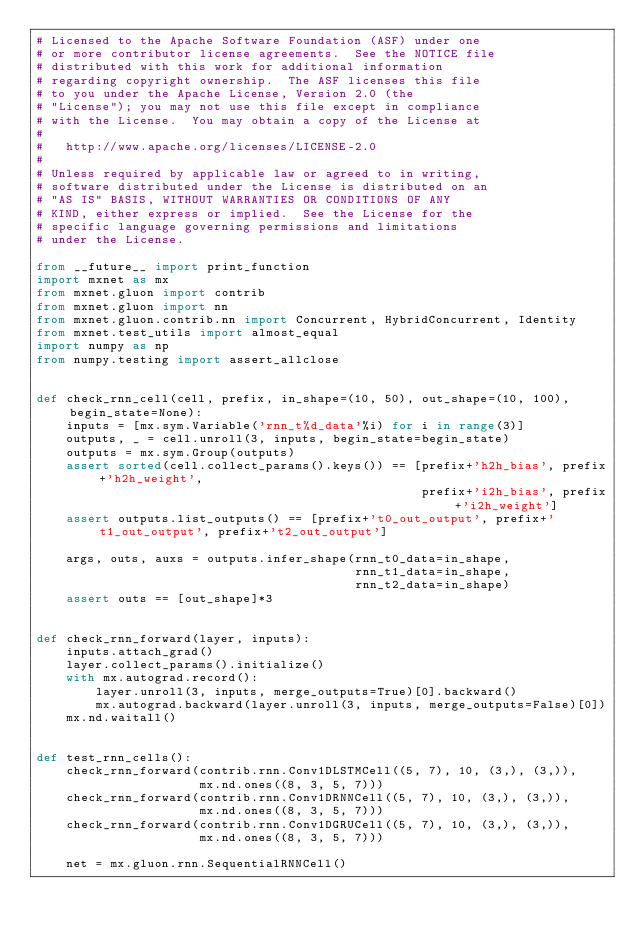Convert code to text. <code><loc_0><loc_0><loc_500><loc_500><_Python_># Licensed to the Apache Software Foundation (ASF) under one
# or more contributor license agreements.  See the NOTICE file
# distributed with this work for additional information
# regarding copyright ownership.  The ASF licenses this file
# to you under the Apache License, Version 2.0 (the
# "License"); you may not use this file except in compliance
# with the License.  You may obtain a copy of the License at
#
#   http://www.apache.org/licenses/LICENSE-2.0
#
# Unless required by applicable law or agreed to in writing,
# software distributed under the License is distributed on an
# "AS IS" BASIS, WITHOUT WARRANTIES OR CONDITIONS OF ANY
# KIND, either express or implied.  See the License for the
# specific language governing permissions and limitations
# under the License.

from __future__ import print_function
import mxnet as mx
from mxnet.gluon import contrib
from mxnet.gluon import nn
from mxnet.gluon.contrib.nn import Concurrent, HybridConcurrent, Identity
from mxnet.test_utils import almost_equal
import numpy as np
from numpy.testing import assert_allclose


def check_rnn_cell(cell, prefix, in_shape=(10, 50), out_shape=(10, 100), begin_state=None):
    inputs = [mx.sym.Variable('rnn_t%d_data'%i) for i in range(3)]
    outputs, _ = cell.unroll(3, inputs, begin_state=begin_state)
    outputs = mx.sym.Group(outputs)
    assert sorted(cell.collect_params().keys()) == [prefix+'h2h_bias', prefix+'h2h_weight',
                                                    prefix+'i2h_bias', prefix+'i2h_weight']
    assert outputs.list_outputs() == [prefix+'t0_out_output', prefix+'t1_out_output', prefix+'t2_out_output']

    args, outs, auxs = outputs.infer_shape(rnn_t0_data=in_shape,
                                           rnn_t1_data=in_shape,
                                           rnn_t2_data=in_shape)
    assert outs == [out_shape]*3


def check_rnn_forward(layer, inputs):
    inputs.attach_grad()
    layer.collect_params().initialize()
    with mx.autograd.record():
        layer.unroll(3, inputs, merge_outputs=True)[0].backward()
        mx.autograd.backward(layer.unroll(3, inputs, merge_outputs=False)[0])
    mx.nd.waitall()


def test_rnn_cells():
    check_rnn_forward(contrib.rnn.Conv1DLSTMCell((5, 7), 10, (3,), (3,)),
                      mx.nd.ones((8, 3, 5, 7)))
    check_rnn_forward(contrib.rnn.Conv1DRNNCell((5, 7), 10, (3,), (3,)),
                      mx.nd.ones((8, 3, 5, 7)))
    check_rnn_forward(contrib.rnn.Conv1DGRUCell((5, 7), 10, (3,), (3,)),
                      mx.nd.ones((8, 3, 5, 7)))

    net = mx.gluon.rnn.SequentialRNNCell()</code> 